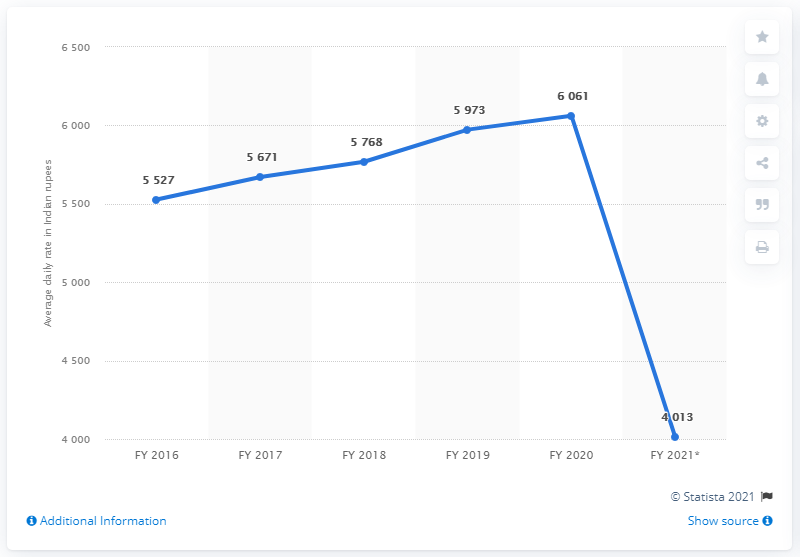List a handful of essential elements in this visual. The hotel attendance rate significantly declined from FY 2016 to FY 2021, with a total decrease of 1514. In the financial year of 2021, the least number of people went to hotels. 